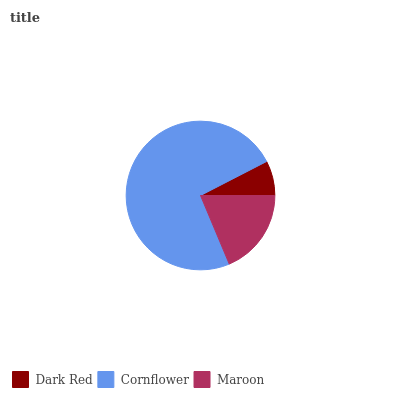Is Dark Red the minimum?
Answer yes or no. Yes. Is Cornflower the maximum?
Answer yes or no. Yes. Is Maroon the minimum?
Answer yes or no. No. Is Maroon the maximum?
Answer yes or no. No. Is Cornflower greater than Maroon?
Answer yes or no. Yes. Is Maroon less than Cornflower?
Answer yes or no. Yes. Is Maroon greater than Cornflower?
Answer yes or no. No. Is Cornflower less than Maroon?
Answer yes or no. No. Is Maroon the high median?
Answer yes or no. Yes. Is Maroon the low median?
Answer yes or no. Yes. Is Dark Red the high median?
Answer yes or no. No. Is Dark Red the low median?
Answer yes or no. No. 